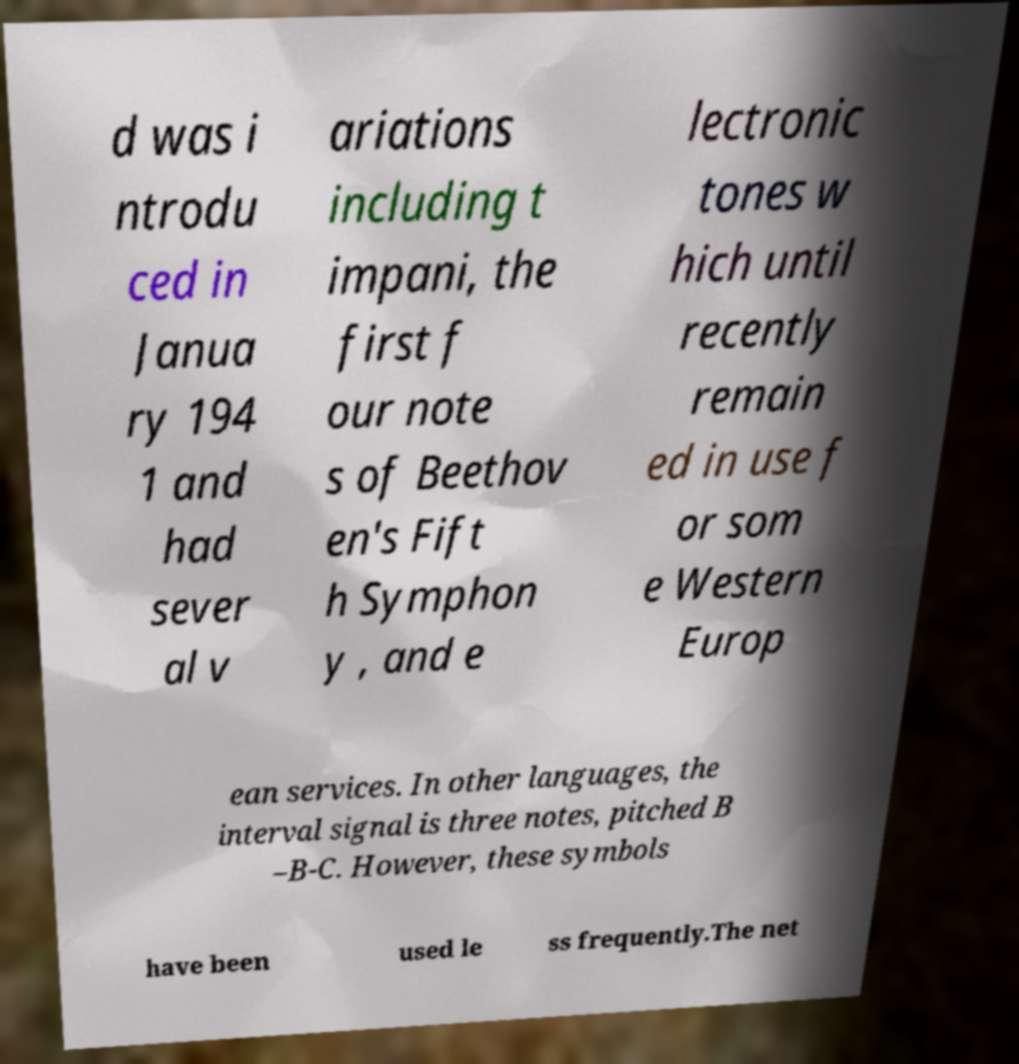There's text embedded in this image that I need extracted. Can you transcribe it verbatim? d was i ntrodu ced in Janua ry 194 1 and had sever al v ariations including t impani, the first f our note s of Beethov en's Fift h Symphon y , and e lectronic tones w hich until recently remain ed in use f or som e Western Europ ean services. In other languages, the interval signal is three notes, pitched B –B-C. However, these symbols have been used le ss frequently.The net 